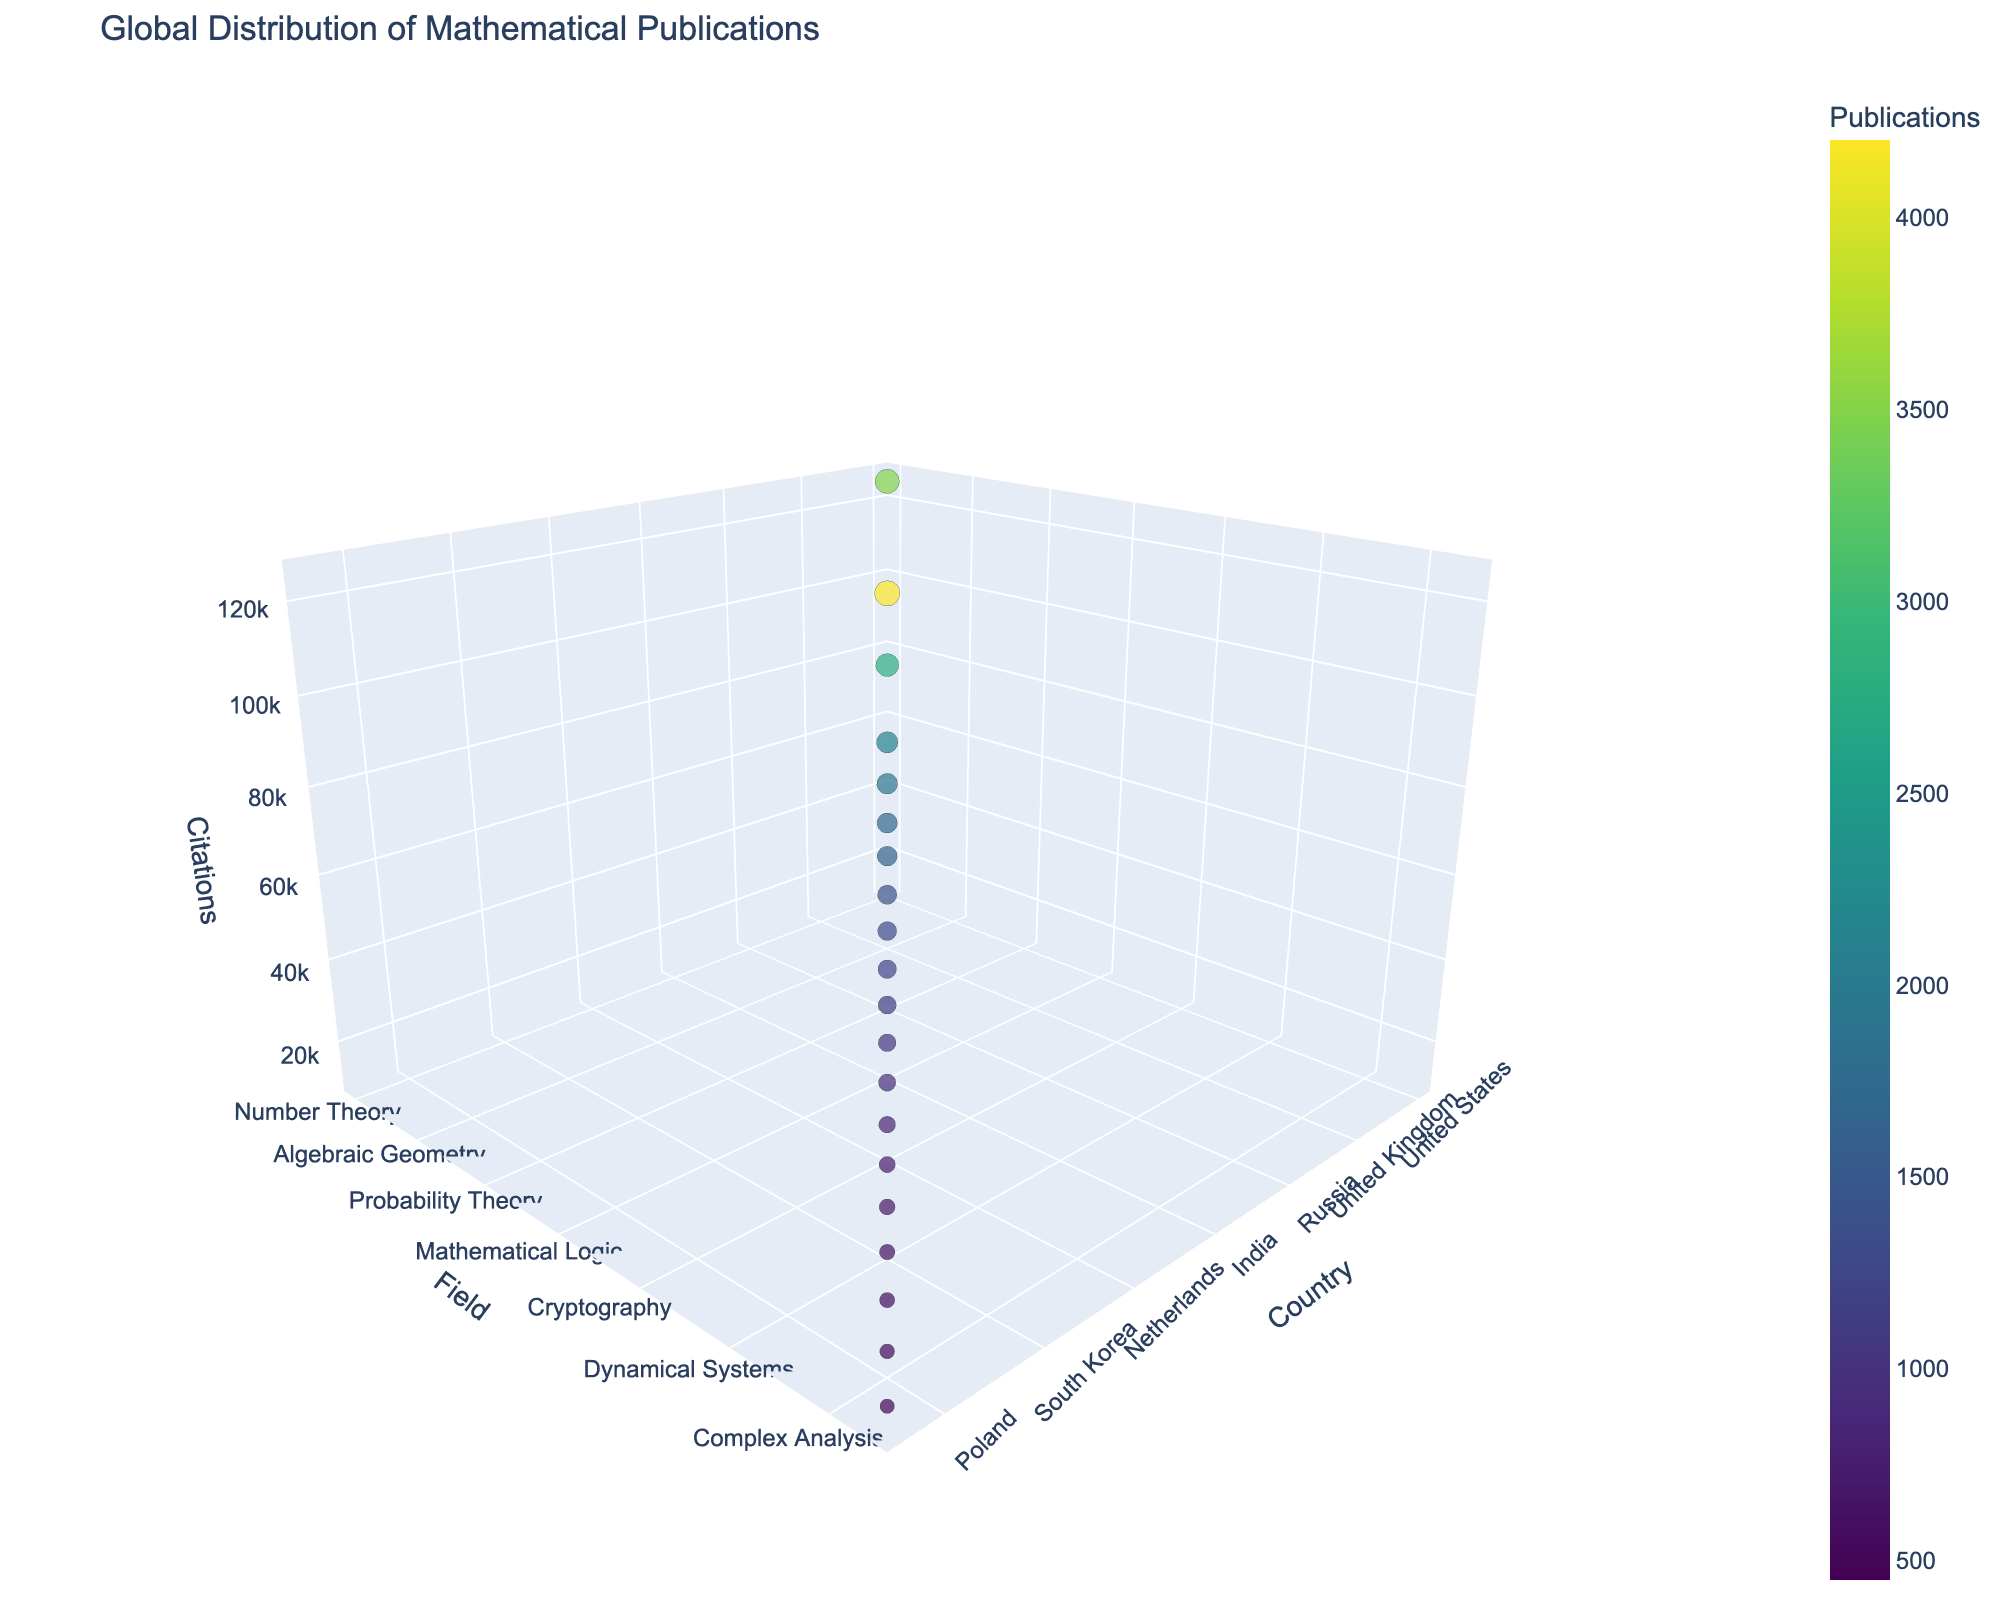What's the title of the figure? To determine the title, you can look at the largest text, usually positioned at the top of the figure.
Answer: Global Distribution of Mathematical Publications What does the z-axis represent? Observing the axis titles, the z-axis (which is typically vertical in 3D charts) is labeled "Citations."
Answer: Citations Which country has the highest number of publications? Focus on the color intensity of the bubbles; darker color corresponds to a higher number of publications. The United States has the darkest bubble.
Answer: United States In which field does Germany have publications? Locate Germany on the x-axis and observe the y-axis value level, which indicates "Mathematical Physics."
Answer: Mathematical Physics What are the field and citation count for the bubble representing Israel? Locate Israel on the x-axis, observe the y-axis for the field and the z-axis value level for citation count. Israel is in "Computational Geometry" with 15,000 citations.
Answer: Computational Geometry, 15000 How many publications does Canada have? Find Canada on the x-axis and hover over the corresponding bubble to see the publication data.
Answer: 1300 Which country has fewer citations: Belgium or Poland? Locate both Belgium and Poland on the x-axis, then check the z-axis values. Belgium's bubble is lower than Poland's.
Answer: Belgium Which countries have fewer than 600 citations in their respective fields? Check for the z-axis values of 600 or lower and note the corresponding countries on the x-axis.
Answer: Belgium and Poland How does the number of citations for Differential Equations in France compare to Number Theory in the United States? Locate France (Differential Equations) and the United States (Number Theory), then compare their z-axis values. The US has significantly more citations (125,000) as compared to France (52,000).
Answer: The United States has more citations Which country has the largest bubble size in the chart? Observe the bubble that visually appears the largest, which correlates with the square root of publications. The United States has the largest bubble size due to having the highest publications.
Answer: United States 